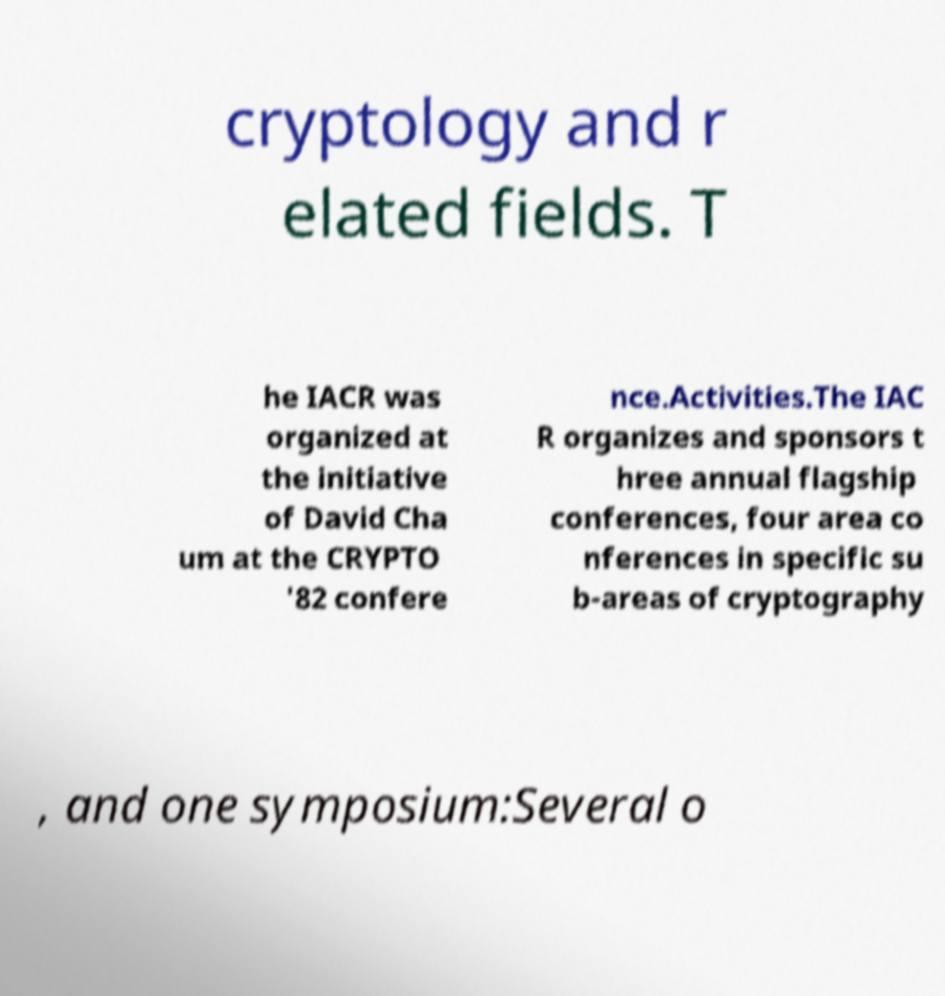Can you read and provide the text displayed in the image?This photo seems to have some interesting text. Can you extract and type it out for me? cryptology and r elated fields. T he IACR was organized at the initiative of David Cha um at the CRYPTO '82 confere nce.Activities.The IAC R organizes and sponsors t hree annual flagship conferences, four area co nferences in specific su b-areas of cryptography , and one symposium:Several o 